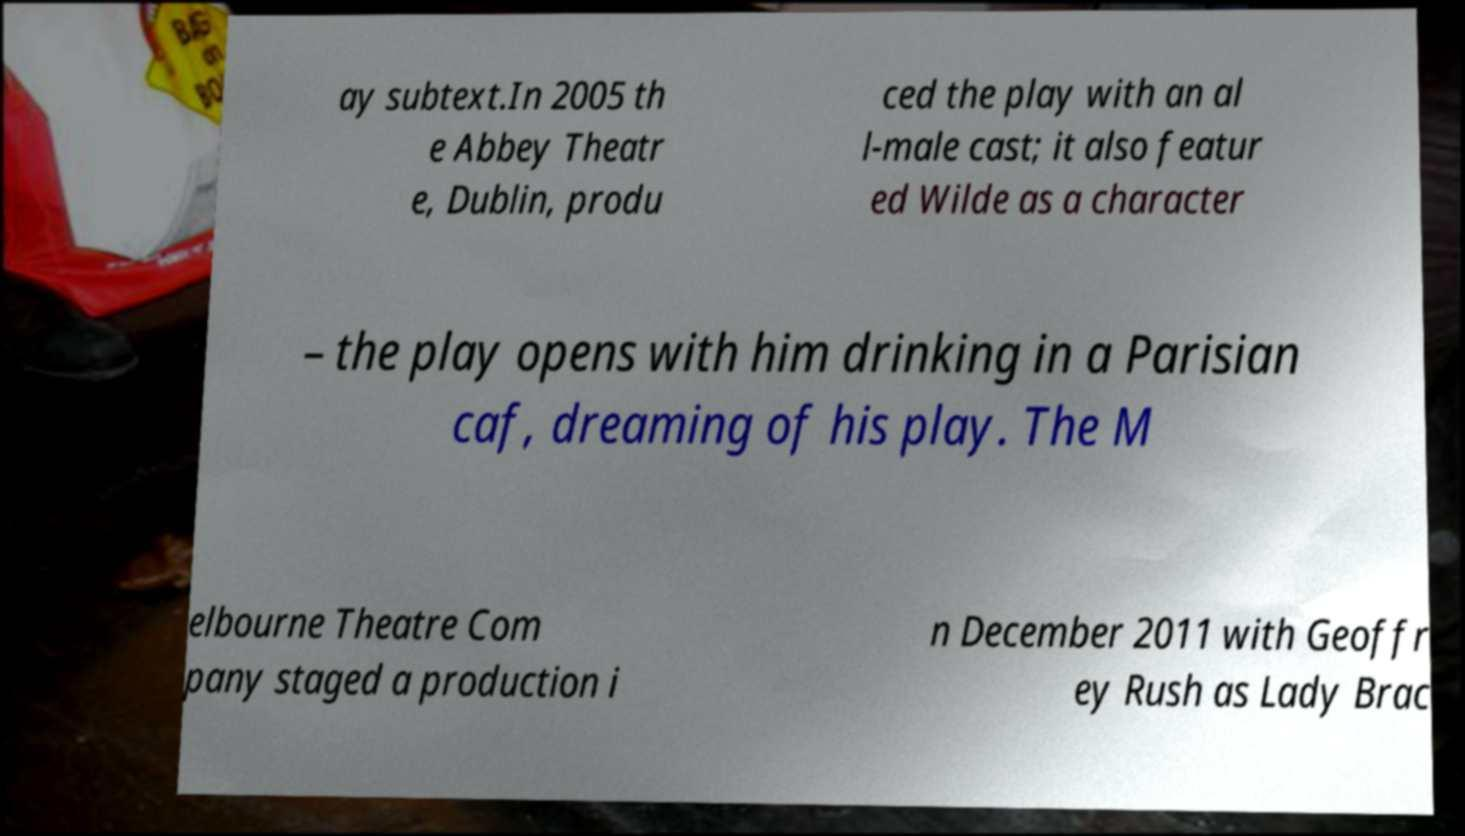Please identify and transcribe the text found in this image. ay subtext.In 2005 th e Abbey Theatr e, Dublin, produ ced the play with an al l-male cast; it also featur ed Wilde as a character – the play opens with him drinking in a Parisian caf, dreaming of his play. The M elbourne Theatre Com pany staged a production i n December 2011 with Geoffr ey Rush as Lady Brac 